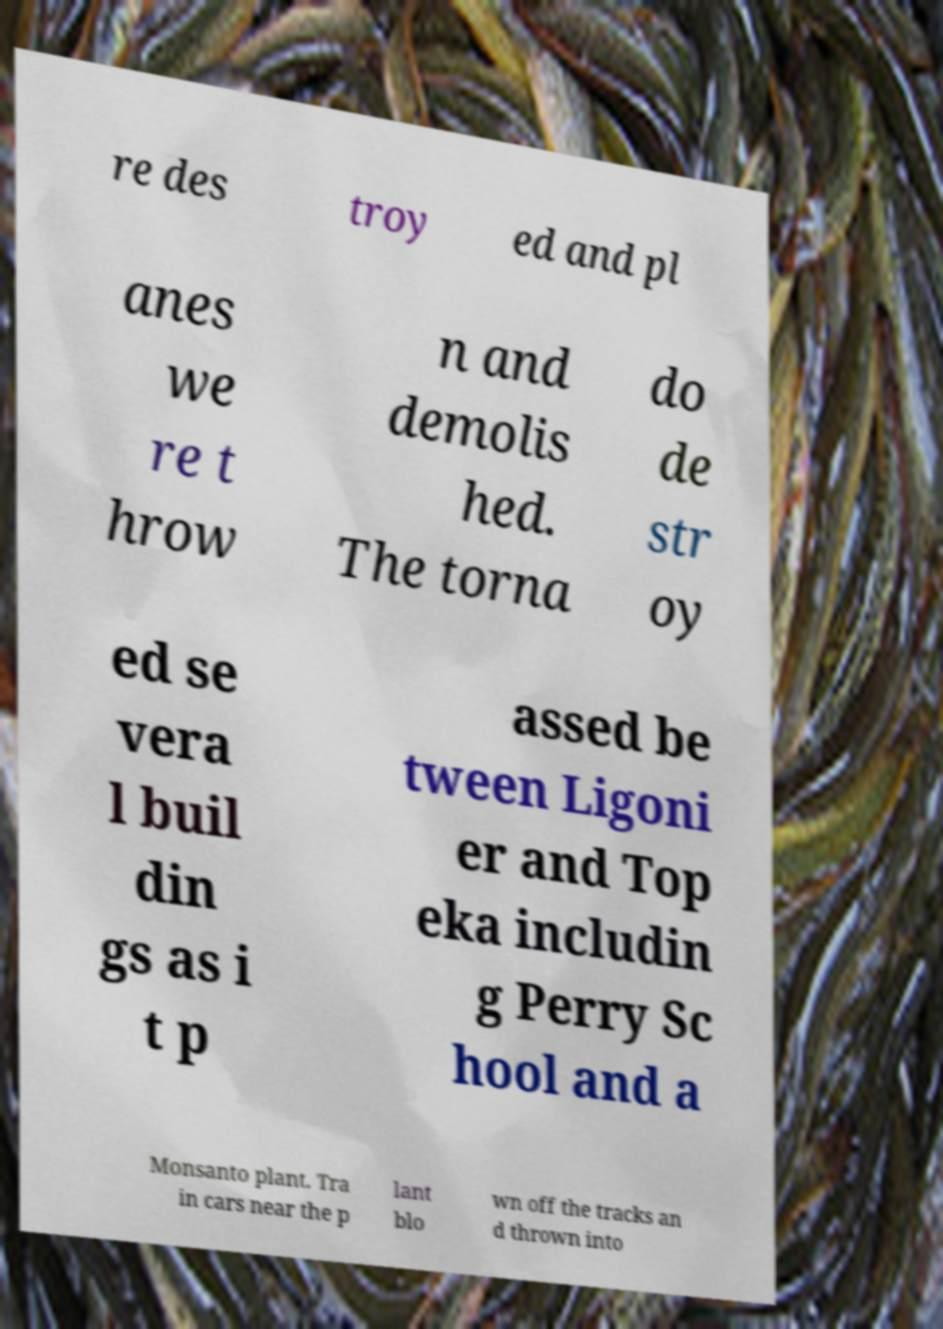There's text embedded in this image that I need extracted. Can you transcribe it verbatim? re des troy ed and pl anes we re t hrow n and demolis hed. The torna do de str oy ed se vera l buil din gs as i t p assed be tween Ligoni er and Top eka includin g Perry Sc hool and a Monsanto plant. Tra in cars near the p lant blo wn off the tracks an d thrown into 